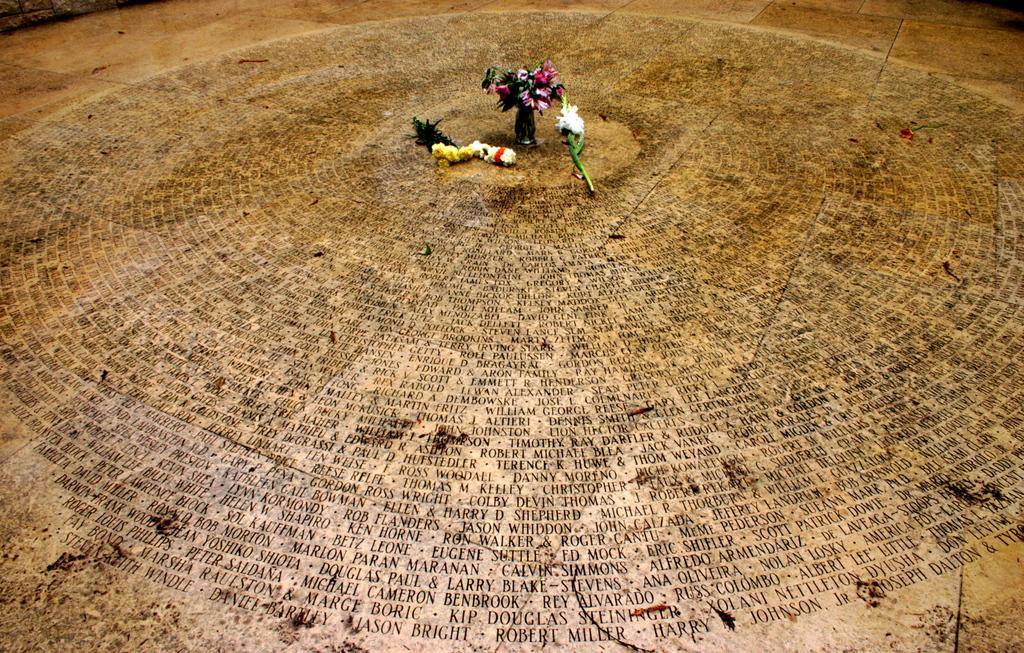What type of plants can be seen in the image? There are flowers in the image. What is the flowers placed in? There is a flower vase in the image. Where are the flowers and vase located? The flowers and vase are on the floor in the image. What is written or depicted on the floor? There is text on the floor in the image. What is the man wearing a veil for in the image? There is no man or veil present in the image. 